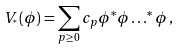Convert formula to latex. <formula><loc_0><loc_0><loc_500><loc_500>V _ { ^ { * } } ( \phi ) = \sum _ { p \geq 0 } c _ { p } \phi ^ { * } \phi \dots ^ { * } \phi \, ,</formula> 